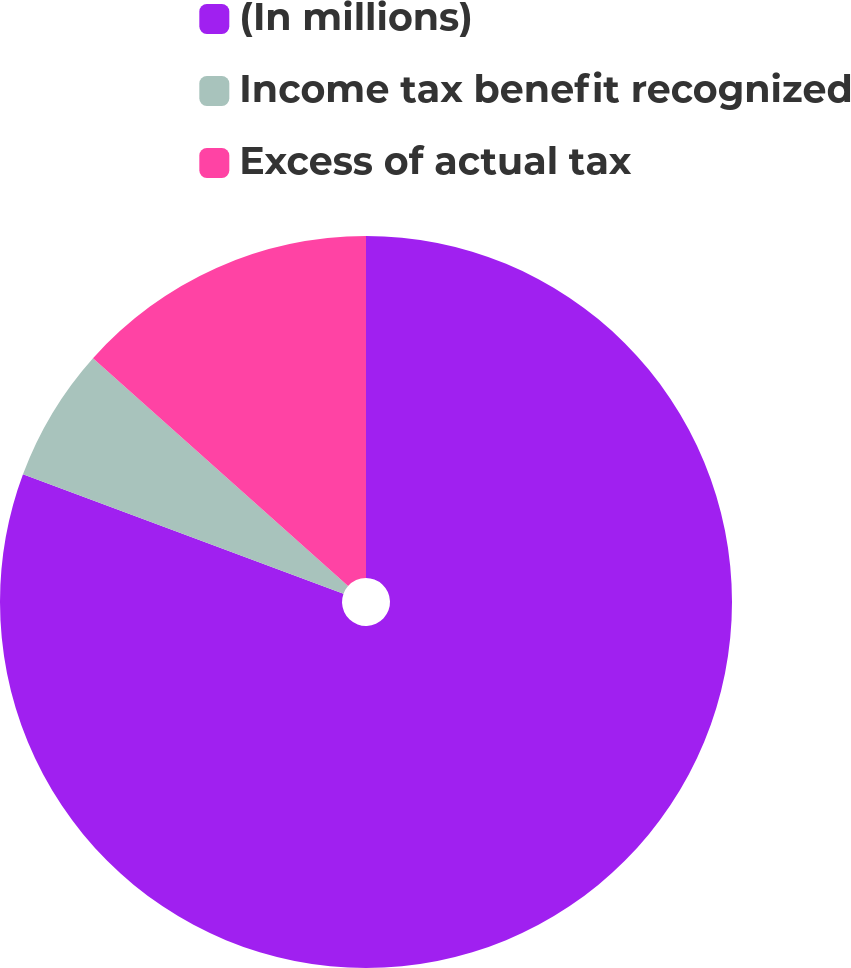<chart> <loc_0><loc_0><loc_500><loc_500><pie_chart><fcel>(In millions)<fcel>Income tax benefit recognized<fcel>Excess of actual tax<nl><fcel>80.67%<fcel>5.93%<fcel>13.4%<nl></chart> 